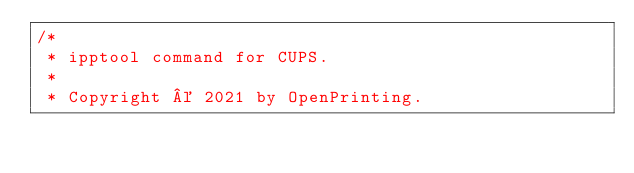Convert code to text. <code><loc_0><loc_0><loc_500><loc_500><_C_>/*
 * ipptool command for CUPS.
 *
 * Copyright © 2021 by OpenPrinting.</code> 